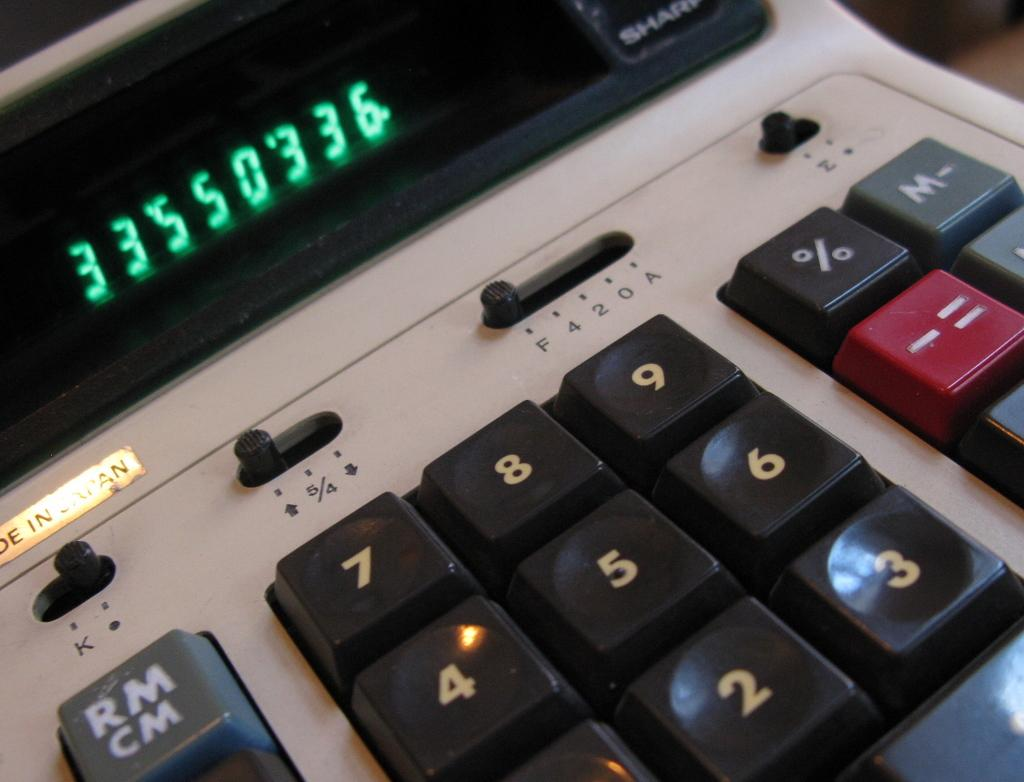<image>
Summarize the visual content of the image. a digital screen that has the numbers 33550336 